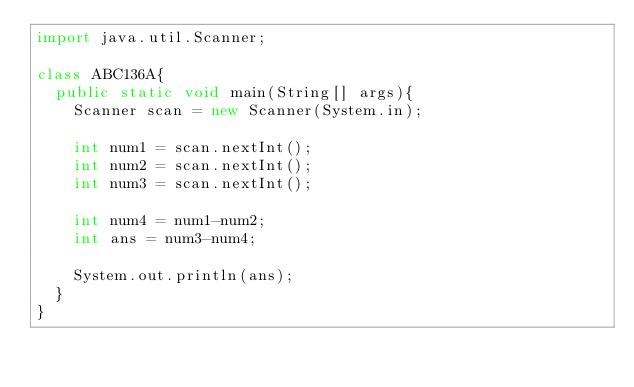Convert code to text. <code><loc_0><loc_0><loc_500><loc_500><_Java_>import java.util.Scanner;

class ABC136A{
	public static void main(String[] args){
		Scanner scan = new Scanner(System.in);
		
		int num1 = scan.nextInt();
		int num2 = scan.nextInt();
		int num3 = scan.nextInt();
		
		int num4 = num1-num2;
		int ans = num3-num4;
		
		System.out.println(ans);
	}
}</code> 